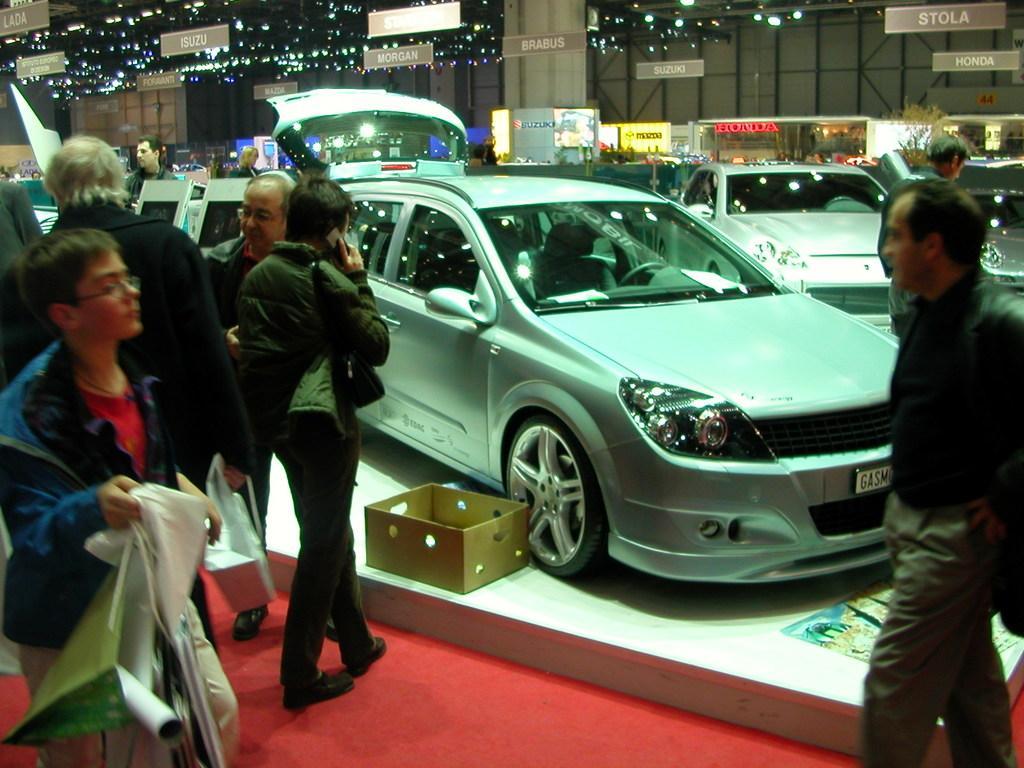How would you summarize this image in a sentence or two? In this image we can see few cars and people standing on the floor, there is a box beside the car, a person is holding cover and few objects in his hands, there are few boards hanged to the ceiling and there are lights to the ceiling and there is a tree. 